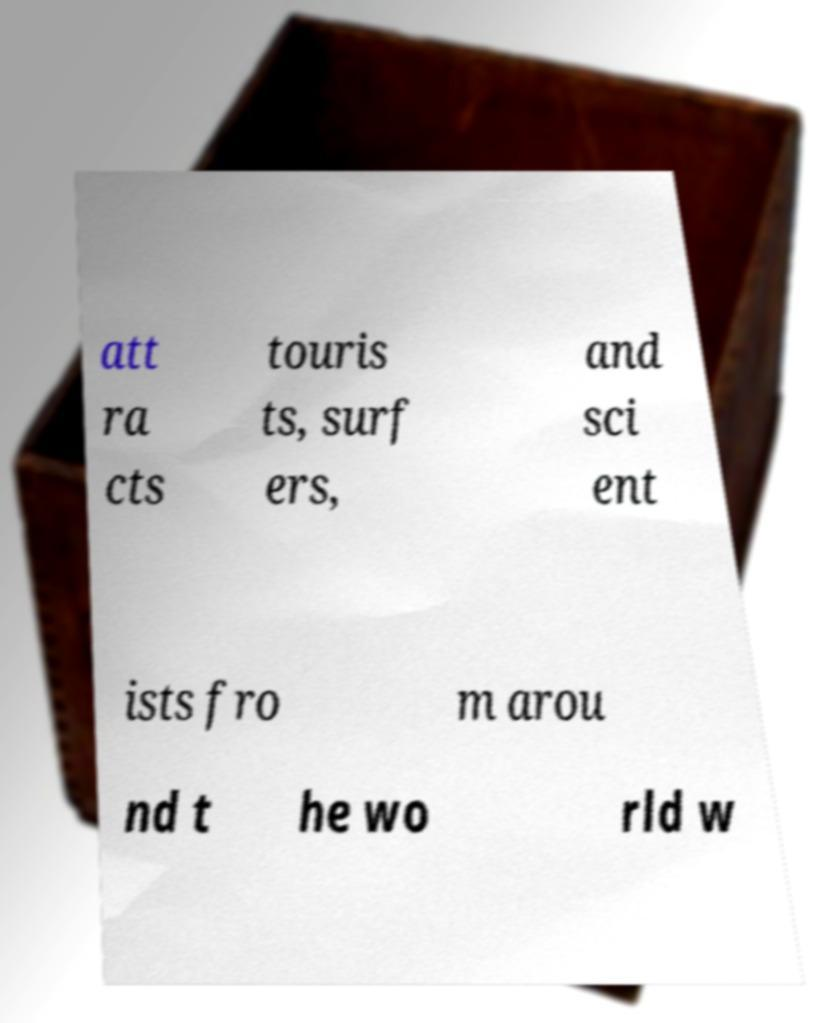For documentation purposes, I need the text within this image transcribed. Could you provide that? att ra cts touris ts, surf ers, and sci ent ists fro m arou nd t he wo rld w 